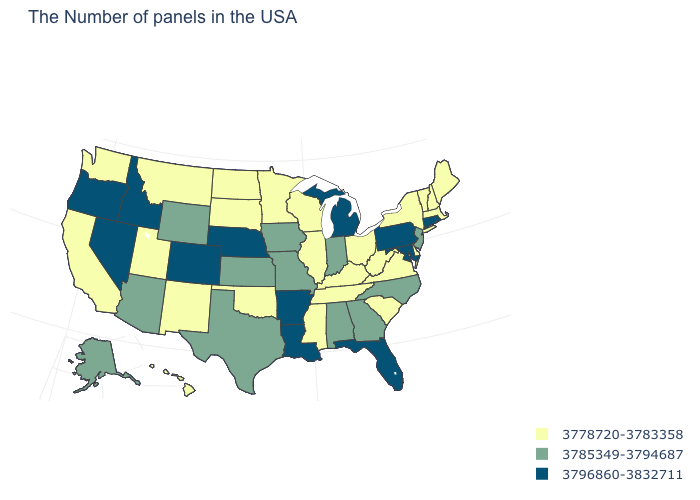What is the lowest value in the USA?
Write a very short answer. 3778720-3783358. What is the highest value in the USA?
Be succinct. 3796860-3832711. What is the value of South Carolina?
Keep it brief. 3778720-3783358. How many symbols are there in the legend?
Answer briefly. 3. What is the lowest value in states that border North Carolina?
Short answer required. 3778720-3783358. What is the value of Pennsylvania?
Short answer required. 3796860-3832711. Which states have the highest value in the USA?
Give a very brief answer. Rhode Island, Connecticut, Maryland, Pennsylvania, Florida, Michigan, Louisiana, Arkansas, Nebraska, Colorado, Idaho, Nevada, Oregon. Name the states that have a value in the range 3796860-3832711?
Be succinct. Rhode Island, Connecticut, Maryland, Pennsylvania, Florida, Michigan, Louisiana, Arkansas, Nebraska, Colorado, Idaho, Nevada, Oregon. Which states have the lowest value in the USA?
Short answer required. Maine, Massachusetts, New Hampshire, Vermont, New York, Delaware, Virginia, South Carolina, West Virginia, Ohio, Kentucky, Tennessee, Wisconsin, Illinois, Mississippi, Minnesota, Oklahoma, South Dakota, North Dakota, New Mexico, Utah, Montana, California, Washington, Hawaii. Name the states that have a value in the range 3778720-3783358?
Answer briefly. Maine, Massachusetts, New Hampshire, Vermont, New York, Delaware, Virginia, South Carolina, West Virginia, Ohio, Kentucky, Tennessee, Wisconsin, Illinois, Mississippi, Minnesota, Oklahoma, South Dakota, North Dakota, New Mexico, Utah, Montana, California, Washington, Hawaii. What is the highest value in the USA?
Quick response, please. 3796860-3832711. Among the states that border Pennsylvania , does New Jersey have the highest value?
Short answer required. No. Name the states that have a value in the range 3796860-3832711?
Answer briefly. Rhode Island, Connecticut, Maryland, Pennsylvania, Florida, Michigan, Louisiana, Arkansas, Nebraska, Colorado, Idaho, Nevada, Oregon. Name the states that have a value in the range 3796860-3832711?
Be succinct. Rhode Island, Connecticut, Maryland, Pennsylvania, Florida, Michigan, Louisiana, Arkansas, Nebraska, Colorado, Idaho, Nevada, Oregon. What is the value of Pennsylvania?
Write a very short answer. 3796860-3832711. 